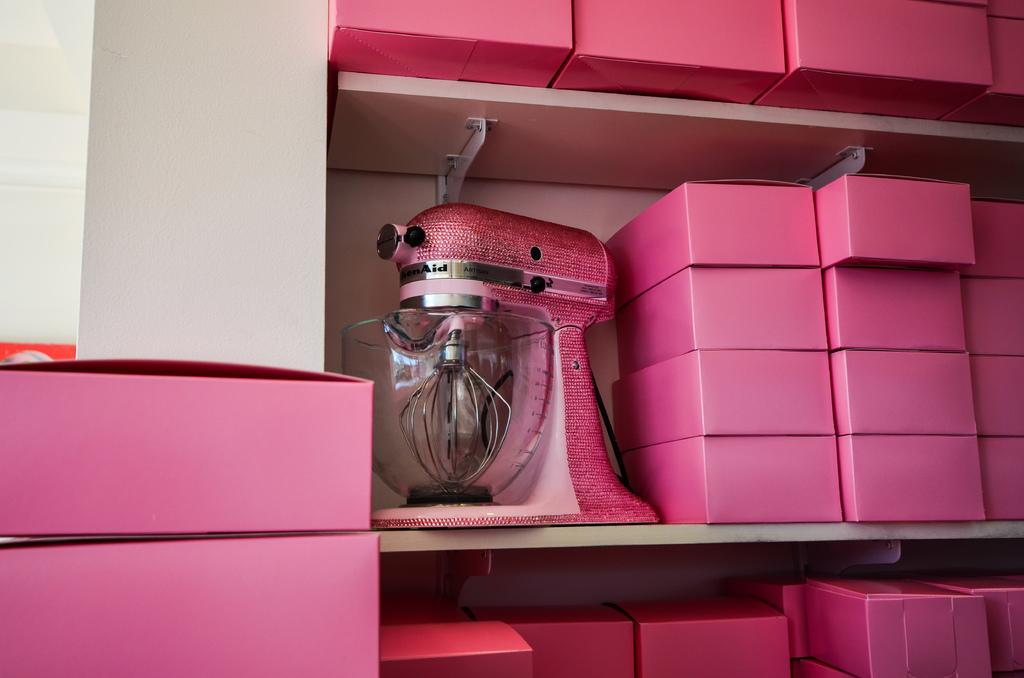What can be seen on the racks in the image? There are pink color boxes on the racks in the image. What appliance is present in the image? There is a juice mixer in the image. What is the color of the juice mixer? The juice mixer is pink in color. What is located next to the juice mixer? There is a glass bowl next to the juice mixer. Is there a swing visible in the image? No, there is no swing present in the image. What type of slope can be seen in the image? There is no slope visible in the image. 